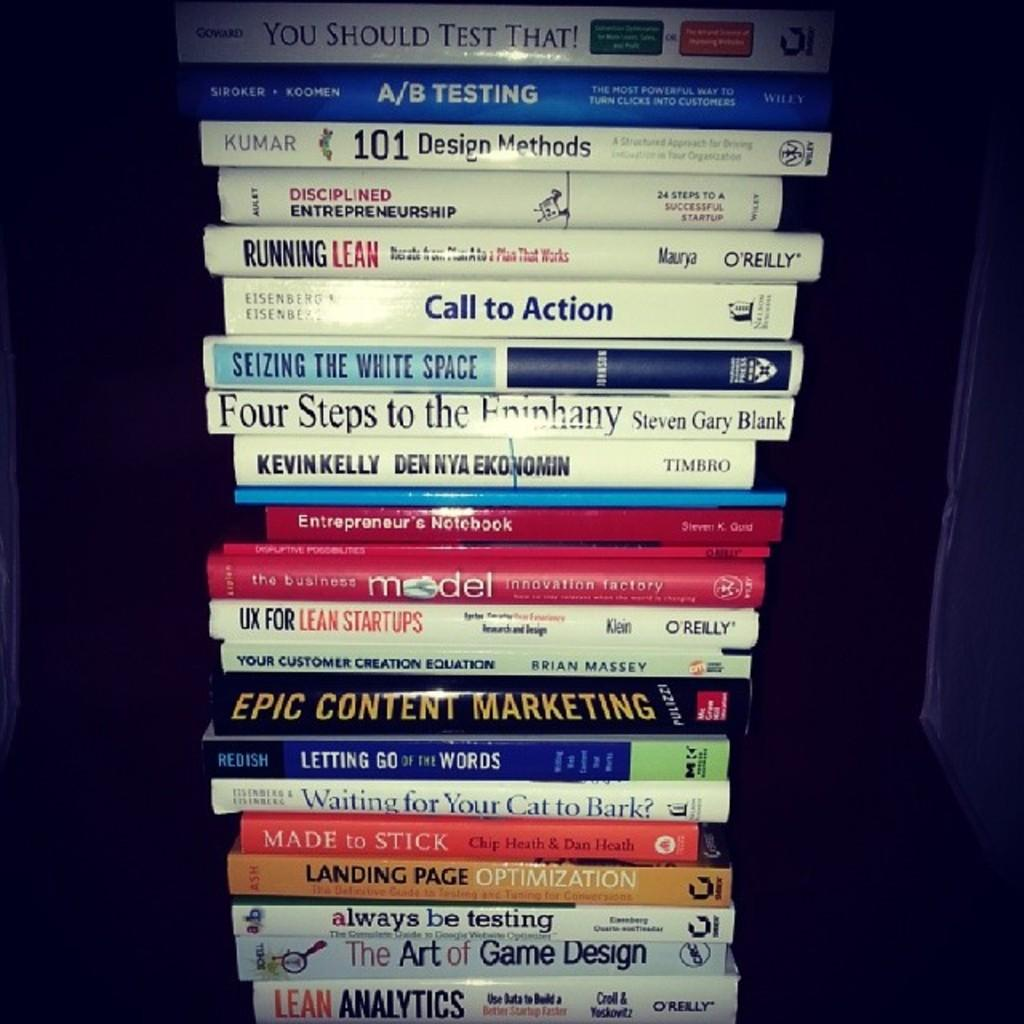<image>
Render a clear and concise summary of the photo. You should test that book on top and Lean Analytics book on the bottom. 